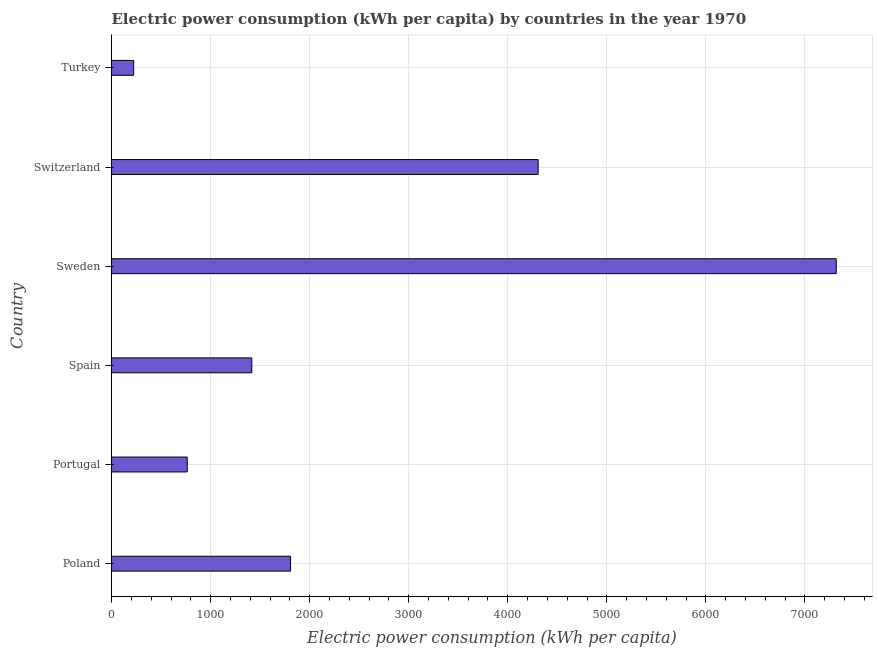Does the graph contain any zero values?
Provide a short and direct response. No. What is the title of the graph?
Your response must be concise. Electric power consumption (kWh per capita) by countries in the year 1970. What is the label or title of the X-axis?
Your answer should be very brief. Electric power consumption (kWh per capita). What is the electric power consumption in Portugal?
Ensure brevity in your answer.  763.9. Across all countries, what is the maximum electric power consumption?
Your answer should be compact. 7315.98. Across all countries, what is the minimum electric power consumption?
Provide a short and direct response. 223.05. In which country was the electric power consumption minimum?
Keep it short and to the point. Turkey. What is the sum of the electric power consumption?
Your response must be concise. 1.58e+04. What is the difference between the electric power consumption in Portugal and Sweden?
Keep it short and to the point. -6552.08. What is the average electric power consumption per country?
Your response must be concise. 2638.69. What is the median electric power consumption?
Make the answer very short. 1611.34. In how many countries, is the electric power consumption greater than 1400 kWh per capita?
Your response must be concise. 4. What is the ratio of the electric power consumption in Portugal to that in Sweden?
Offer a terse response. 0.1. Is the difference between the electric power consumption in Portugal and Spain greater than the difference between any two countries?
Your answer should be very brief. No. What is the difference between the highest and the second highest electric power consumption?
Give a very brief answer. 3009.47. Is the sum of the electric power consumption in Spain and Switzerland greater than the maximum electric power consumption across all countries?
Your response must be concise. No. What is the difference between the highest and the lowest electric power consumption?
Give a very brief answer. 7092.93. How many bars are there?
Give a very brief answer. 6. Are all the bars in the graph horizontal?
Provide a succinct answer. Yes. What is the Electric power consumption (kWh per capita) of Poland?
Your response must be concise. 1806.83. What is the Electric power consumption (kWh per capita) of Portugal?
Ensure brevity in your answer.  763.9. What is the Electric power consumption (kWh per capita) in Spain?
Make the answer very short. 1415.84. What is the Electric power consumption (kWh per capita) of Sweden?
Ensure brevity in your answer.  7315.98. What is the Electric power consumption (kWh per capita) in Switzerland?
Your answer should be compact. 4306.51. What is the Electric power consumption (kWh per capita) of Turkey?
Ensure brevity in your answer.  223.05. What is the difference between the Electric power consumption (kWh per capita) in Poland and Portugal?
Give a very brief answer. 1042.93. What is the difference between the Electric power consumption (kWh per capita) in Poland and Spain?
Give a very brief answer. 390.99. What is the difference between the Electric power consumption (kWh per capita) in Poland and Sweden?
Offer a very short reply. -5509.15. What is the difference between the Electric power consumption (kWh per capita) in Poland and Switzerland?
Your answer should be very brief. -2499.67. What is the difference between the Electric power consumption (kWh per capita) in Poland and Turkey?
Make the answer very short. 1583.78. What is the difference between the Electric power consumption (kWh per capita) in Portugal and Spain?
Provide a short and direct response. -651.94. What is the difference between the Electric power consumption (kWh per capita) in Portugal and Sweden?
Give a very brief answer. -6552.08. What is the difference between the Electric power consumption (kWh per capita) in Portugal and Switzerland?
Make the answer very short. -3542.61. What is the difference between the Electric power consumption (kWh per capita) in Portugal and Turkey?
Provide a short and direct response. 540.85. What is the difference between the Electric power consumption (kWh per capita) in Spain and Sweden?
Ensure brevity in your answer.  -5900.14. What is the difference between the Electric power consumption (kWh per capita) in Spain and Switzerland?
Your answer should be compact. -2890.67. What is the difference between the Electric power consumption (kWh per capita) in Spain and Turkey?
Your answer should be compact. 1192.79. What is the difference between the Electric power consumption (kWh per capita) in Sweden and Switzerland?
Provide a succinct answer. 3009.47. What is the difference between the Electric power consumption (kWh per capita) in Sweden and Turkey?
Your answer should be very brief. 7092.93. What is the difference between the Electric power consumption (kWh per capita) in Switzerland and Turkey?
Your response must be concise. 4083.46. What is the ratio of the Electric power consumption (kWh per capita) in Poland to that in Portugal?
Offer a terse response. 2.37. What is the ratio of the Electric power consumption (kWh per capita) in Poland to that in Spain?
Your answer should be very brief. 1.28. What is the ratio of the Electric power consumption (kWh per capita) in Poland to that in Sweden?
Offer a very short reply. 0.25. What is the ratio of the Electric power consumption (kWh per capita) in Poland to that in Switzerland?
Keep it short and to the point. 0.42. What is the ratio of the Electric power consumption (kWh per capita) in Portugal to that in Spain?
Provide a succinct answer. 0.54. What is the ratio of the Electric power consumption (kWh per capita) in Portugal to that in Sweden?
Your response must be concise. 0.1. What is the ratio of the Electric power consumption (kWh per capita) in Portugal to that in Switzerland?
Your answer should be very brief. 0.18. What is the ratio of the Electric power consumption (kWh per capita) in Portugal to that in Turkey?
Provide a short and direct response. 3.42. What is the ratio of the Electric power consumption (kWh per capita) in Spain to that in Sweden?
Your answer should be compact. 0.19. What is the ratio of the Electric power consumption (kWh per capita) in Spain to that in Switzerland?
Your answer should be very brief. 0.33. What is the ratio of the Electric power consumption (kWh per capita) in Spain to that in Turkey?
Keep it short and to the point. 6.35. What is the ratio of the Electric power consumption (kWh per capita) in Sweden to that in Switzerland?
Ensure brevity in your answer.  1.7. What is the ratio of the Electric power consumption (kWh per capita) in Sweden to that in Turkey?
Offer a very short reply. 32.8. What is the ratio of the Electric power consumption (kWh per capita) in Switzerland to that in Turkey?
Your answer should be very brief. 19.31. 